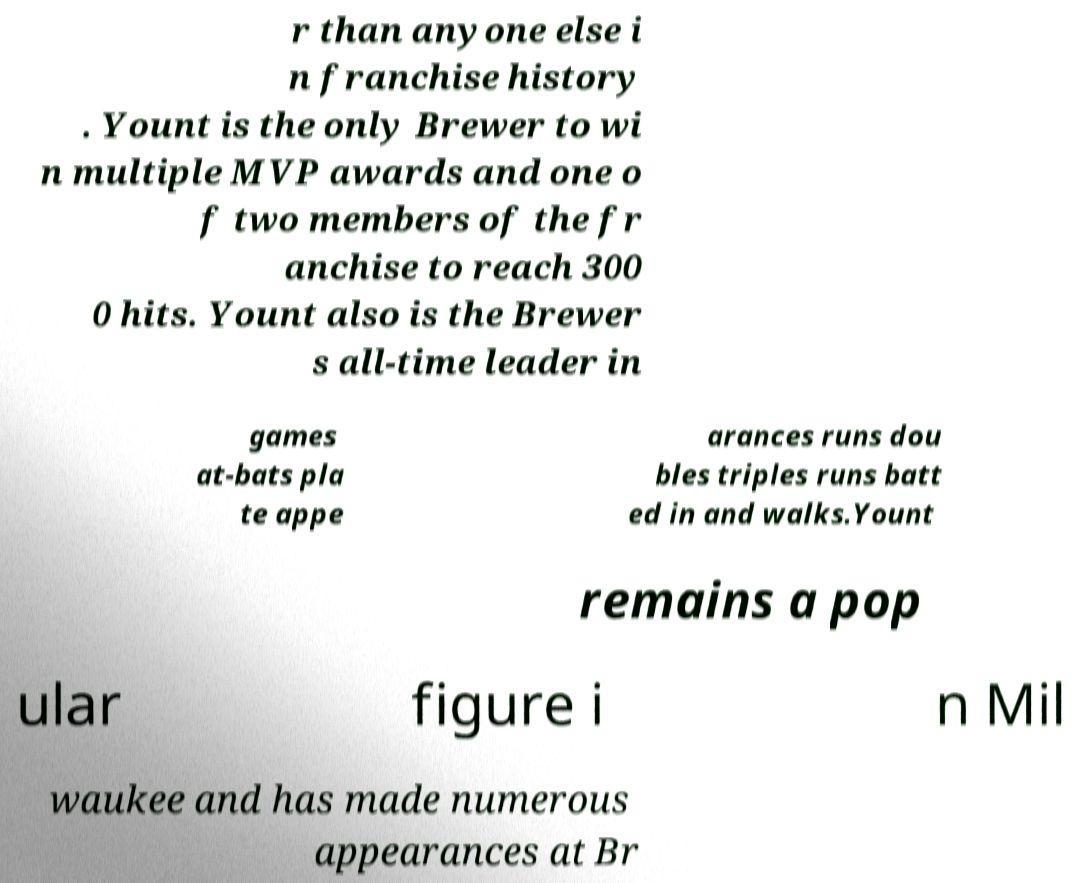There's text embedded in this image that I need extracted. Can you transcribe it verbatim? r than anyone else i n franchise history . Yount is the only Brewer to wi n multiple MVP awards and one o f two members of the fr anchise to reach 300 0 hits. Yount also is the Brewer s all-time leader in games at-bats pla te appe arances runs dou bles triples runs batt ed in and walks.Yount remains a pop ular figure i n Mil waukee and has made numerous appearances at Br 